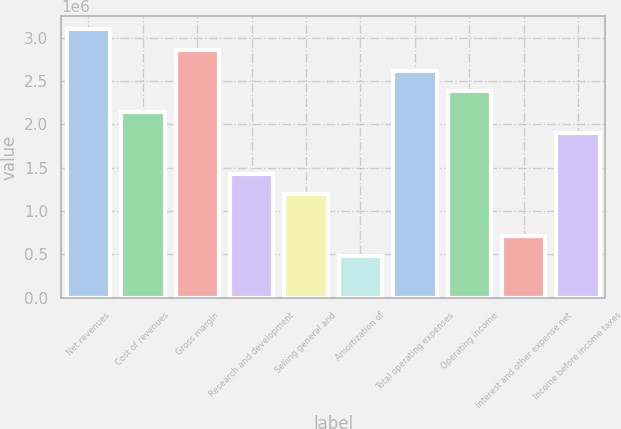Convert chart. <chart><loc_0><loc_0><loc_500><loc_500><bar_chart><fcel>Net revenues<fcel>Cost of revenues<fcel>Gross margin<fcel>Research and development<fcel>Selling general and<fcel>Amortization of<fcel>Total operating expenses<fcel>Operating income<fcel>Interest and other expense net<fcel>Income before income taxes<nl><fcel>3.09729e+06<fcel>2.14428e+06<fcel>2.85904e+06<fcel>1.42952e+06<fcel>1.19127e+06<fcel>476508<fcel>2.62078e+06<fcel>2.38253e+06<fcel>714761<fcel>1.90603e+06<nl></chart> 